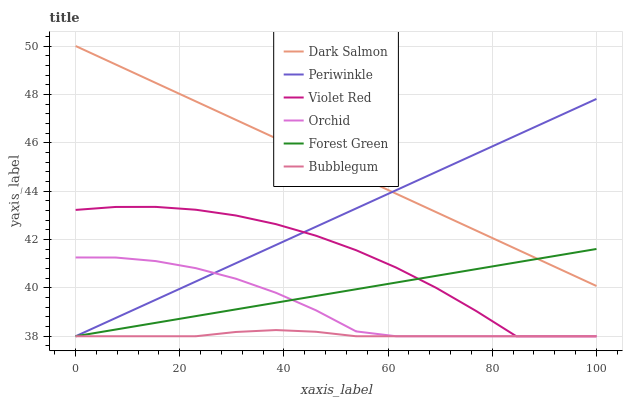Does Bubblegum have the minimum area under the curve?
Answer yes or no. Yes. Does Dark Salmon have the maximum area under the curve?
Answer yes or no. Yes. Does Dark Salmon have the minimum area under the curve?
Answer yes or no. No. Does Bubblegum have the maximum area under the curve?
Answer yes or no. No. Is Dark Salmon the smoothest?
Answer yes or no. Yes. Is Violet Red the roughest?
Answer yes or no. Yes. Is Bubblegum the smoothest?
Answer yes or no. No. Is Bubblegum the roughest?
Answer yes or no. No. Does Violet Red have the lowest value?
Answer yes or no. Yes. Does Dark Salmon have the lowest value?
Answer yes or no. No. Does Dark Salmon have the highest value?
Answer yes or no. Yes. Does Bubblegum have the highest value?
Answer yes or no. No. Is Violet Red less than Dark Salmon?
Answer yes or no. Yes. Is Dark Salmon greater than Orchid?
Answer yes or no. Yes. Does Bubblegum intersect Periwinkle?
Answer yes or no. Yes. Is Bubblegum less than Periwinkle?
Answer yes or no. No. Is Bubblegum greater than Periwinkle?
Answer yes or no. No. Does Violet Red intersect Dark Salmon?
Answer yes or no. No. 